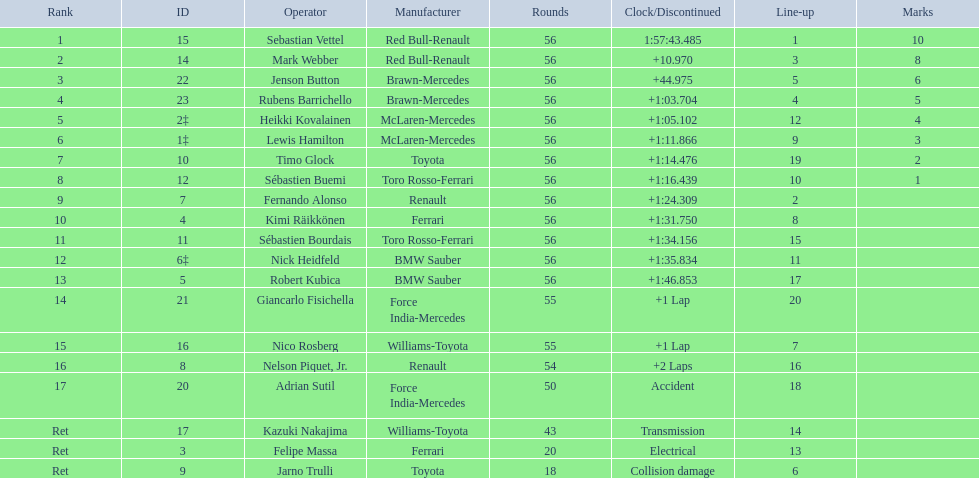Who was the slowest driver to finish the race? Robert Kubica. 